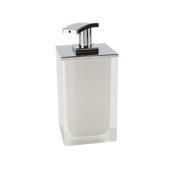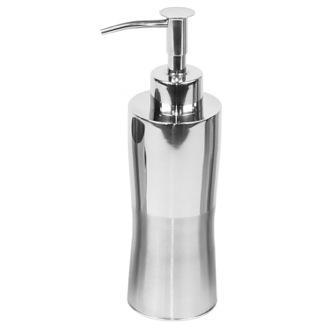The first image is the image on the left, the second image is the image on the right. Given the left and right images, does the statement "The dispenser on the left is rectangular in shape." hold true? Answer yes or no. Yes. The first image is the image on the left, the second image is the image on the right. Given the left and right images, does the statement "The dispenser in the image on the right is round" hold true? Answer yes or no. Yes. 